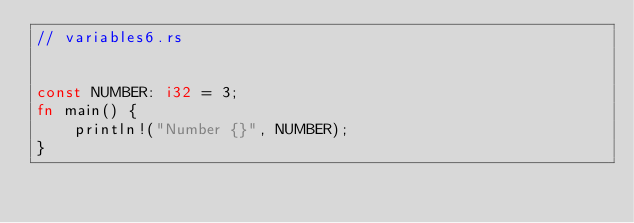<code> <loc_0><loc_0><loc_500><loc_500><_Rust_>// variables6.rs


const NUMBER: i32 = 3;
fn main() {
    println!("Number {}", NUMBER);
}
</code> 